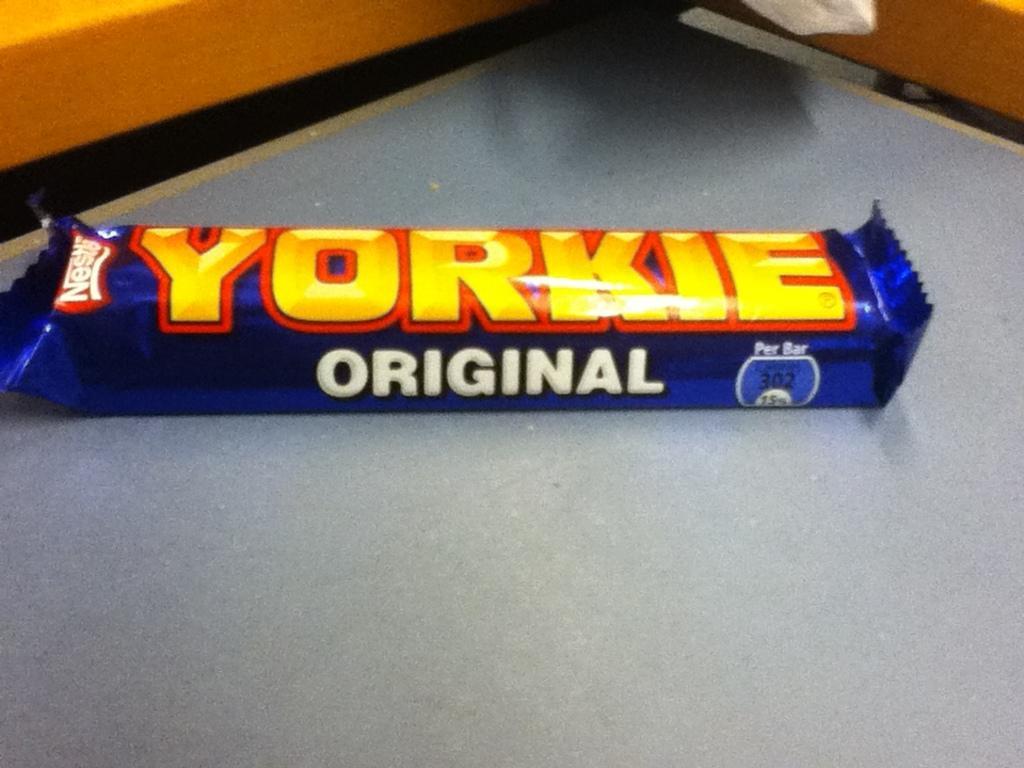Describe this image in one or two sentences. In this image there is a chocolate on the table. 